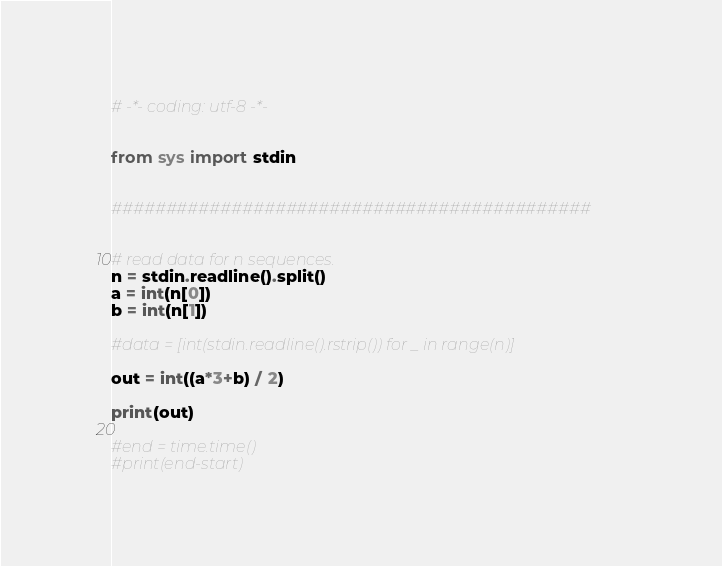Convert code to text. <code><loc_0><loc_0><loc_500><loc_500><_Python_># -*- coding: utf-8 -*-


from sys import stdin


############################################


# read data for n sequences.
n = stdin.readline().split()
a = int(n[0])
b = int(n[1])

#data = [int(stdin.readline().rstrip()) for _ in range(n)]

out = int((a*3+b) / 2)

print(out)

#end = time.time()
#print(end-start)</code> 